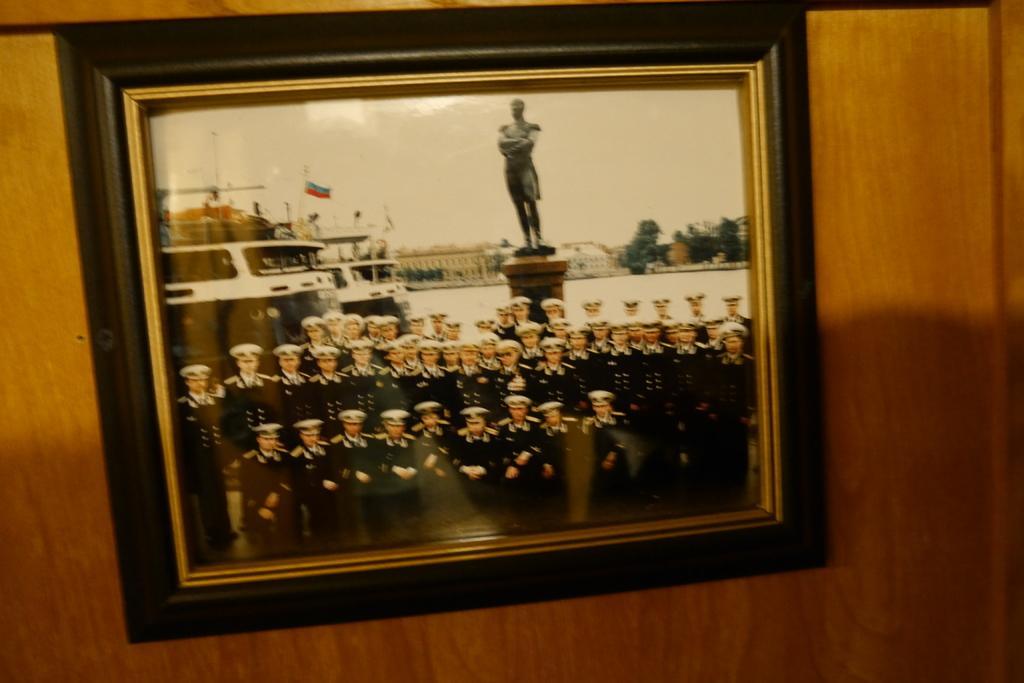In one or two sentences, can you explain what this image depicts? In this picture we can observe a photo frame of soldiers wearing coats and caps on their heads. We can observe a statue in this photo frame. This photo frame is fixed to the brown color wall. 